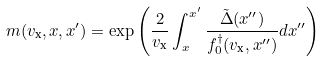<formula> <loc_0><loc_0><loc_500><loc_500>m ( v _ { \text {x} } , x , x ^ { \prime } ) = \exp \left ( \frac { 2 } { v _ { \text {x} } } \int _ { x } ^ { x ^ { \prime } } \frac { \tilde { \Delta } ( x ^ { \prime \prime } ) } { f ^ { \dagger } _ { 0 } ( v _ { \text {x} } , x ^ { \prime \prime } ) } d x ^ { \prime \prime } \right )</formula> 